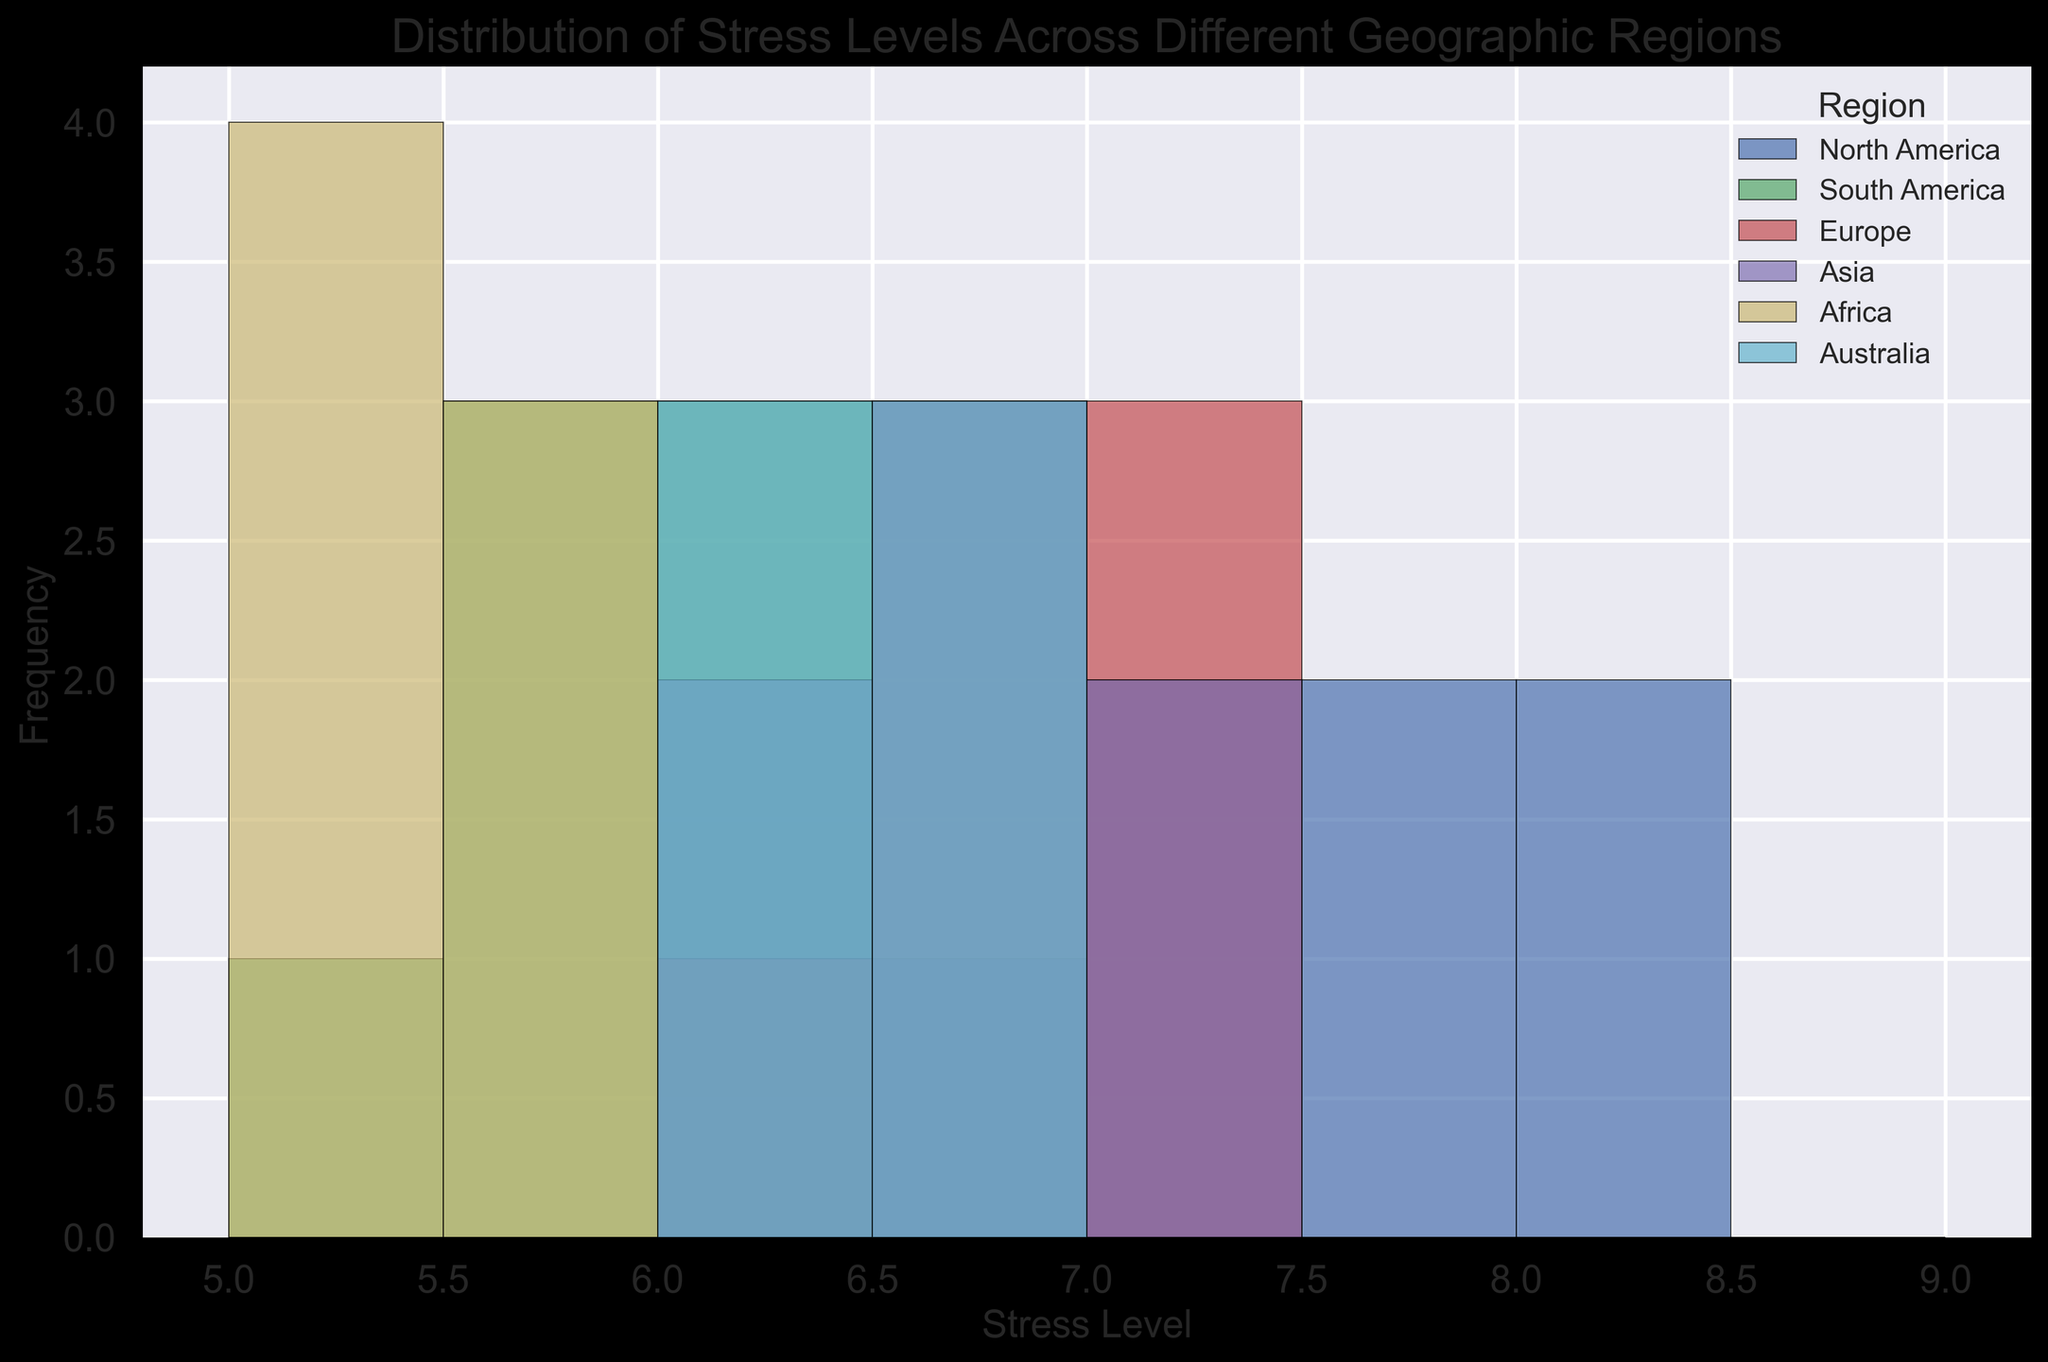Which region has the highest overall stress levels? By observing the histogram, we need to identify the region with the highest frequency of high stress levels in the bins closest to the top range (8-8.5). North America has the most occurrences in this range.
Answer: North America Which region shows the most consistent stress levels? Consistency can be determined by the spread and frequency of the stress levels. Africa has its stress levels tightly clustered around the 5-6 range, showing less variability compared to other regions.
Answer: Africa How does the frequency of stress levels in Europe compare to those in Asia? By comparing the histograms for Europe and Asia, we can see that both regions have similar ranges, but the frequencies of stress levels above 6.5 are slightly higher in Asia than in Europe.
Answer: Asia has slightly higher frequencies above 6.5 What is the median stress level for North America? The median is the middle value in a sorted list. For North America, the sorted values are [6.7, 7.2, 7.4, 7.8, 7.9, 8.0, 8.1]. Since there are 7 values, the median is the 4th value, which is 7.8.
Answer: 7.8 Compare the stress level distributions of North America and South America? North America has stress levels spread broadly across higher values (6.7 to 8.1), while South America’s stress levels are spread more narrowly around lower values (5.3 to 6.4). North America exhibits a higher stress level distribution than South America.
Answer: North America has higher stress levels Which region has the lowest minimum stress level, and what is that value? By observing the histograms, the lowest minimum stress level occurs in Africa, which has frequencies starting from 5.1.
Answer: Africa, 5.1 Between Asia and Australia, which has a higher peak in their stress level histogram? Peaks in histograms represent the highest frequencies in specific bins. Both Asia and Australia peek around the 6.5-7.0 range, but Asia's peak is slightly higher.
Answer: Asia What is the mean stress level for Europe? To find the mean, add all stress levels for Europe (6.4, 6.5, 6.6, 6.8, 7.0, 7.1, 7.2) and divide by the number of entries (7). The sum is 47.6 and dividing by 7 gives approximately 6.8.
Answer: 6.8 Which regions have their stress levels primarily between 6 and 7? Examining the bins, Europe, Asia, and Australia have most of their frequencies clustered between the 6-7 range.
Answer: Europe, Asia, Australia 